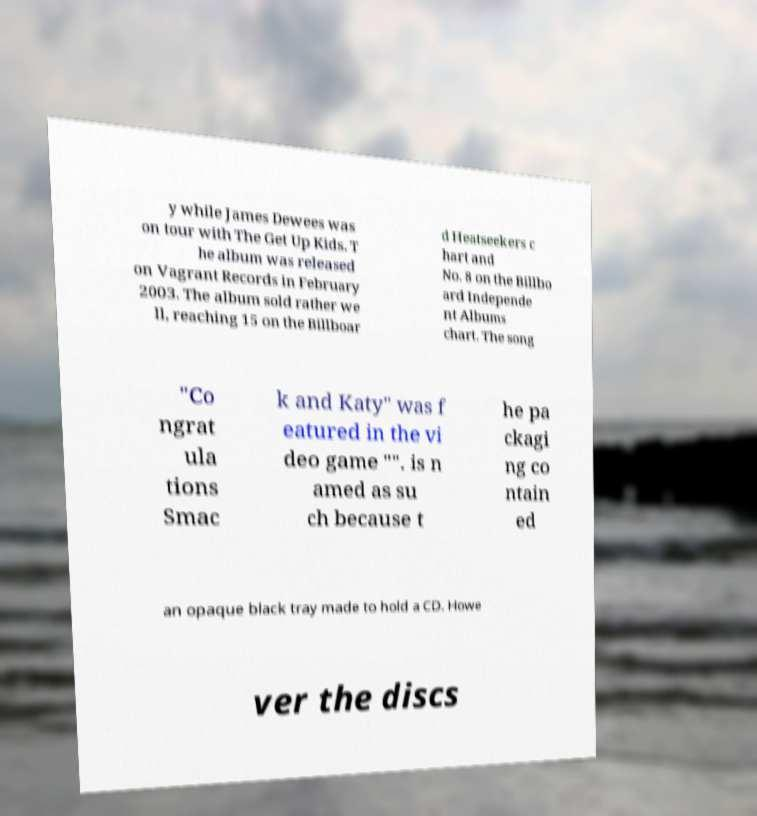Please read and relay the text visible in this image. What does it say? y while James Dewees was on tour with The Get Up Kids. T he album was released on Vagrant Records in February 2003. The album sold rather we ll, reaching 15 on the Billboar d Heatseekers c hart and No. 8 on the Billbo ard Independe nt Albums chart. The song "Co ngrat ula tions Smac k and Katy" was f eatured in the vi deo game "". is n amed as su ch because t he pa ckagi ng co ntain ed an opaque black tray made to hold a CD. Howe ver the discs 